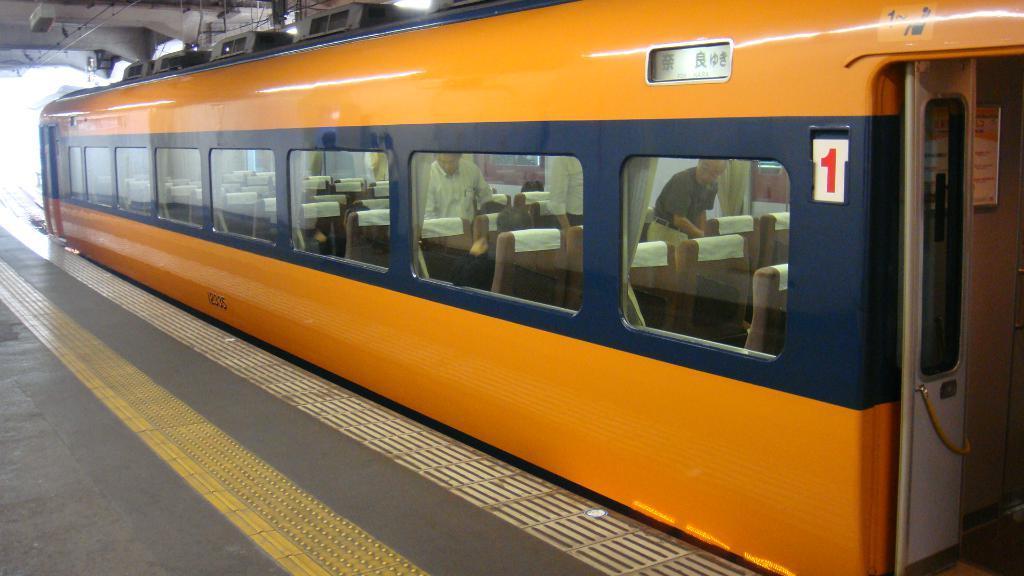Could you give a brief overview of what you see in this image? In this picture we can see a train and through window glasses we can see people. This is a door and platform. 